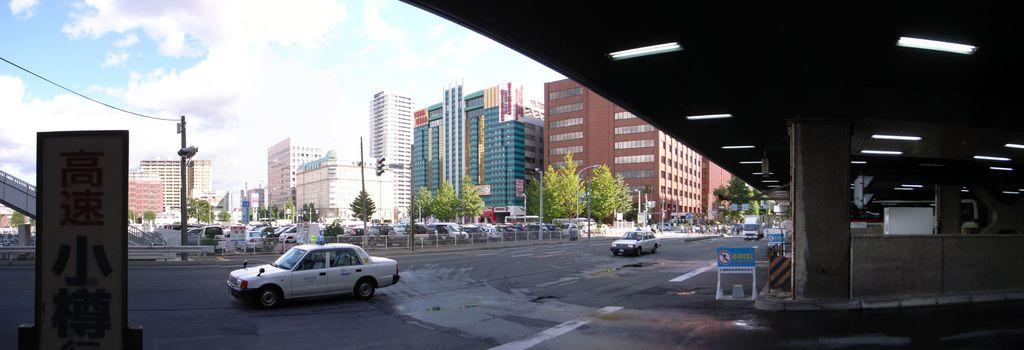What type of structures can be seen in the image? There are buildings in the image. What natural elements are present in the image? There are trees in the image. What architectural features can be observed in the image? There are windows, poles, traffic signals, and fencing in the image. What man-made objects are visible in the image? There are vehicles, sign boards, and boards on the road in the image. What is the color of the sky in the image? The sky is in white and blue color. Can you tell me which team is playing in the image? There is no team playing in the image; it features buildings, trees, and other urban elements. Is there a cat visible in the image? There is no cat present in the image. 